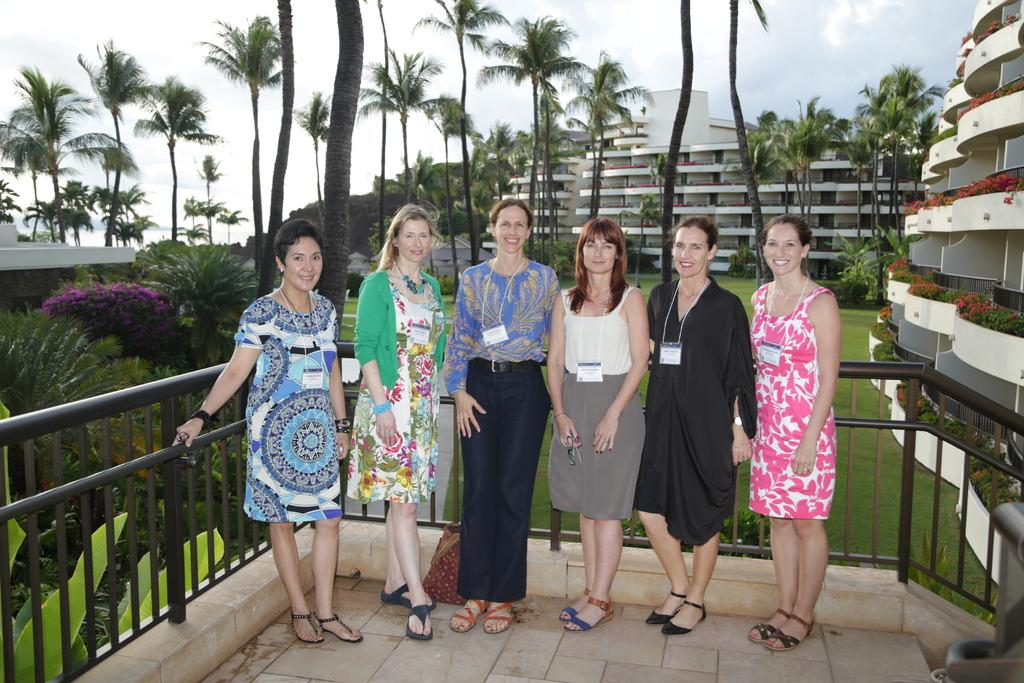Who is present in the image? There are ladies in the image. What are the ladies wearing? The ladies are wearing access cards. Where are the ladies located in the image? The ladies are standing in a balcony. What type of vegetation can be seen in the image? There are plants, trees, and flowers in the image. What structures are visible in the image? There are buildings in the image. What is visible in the sky in the image? The sky is visible in the image. What type of fowl can be seen flying in the image? There are no fowl visible in the image; only ladies, plants, trees, flowers, buildings, and the sky are present. 